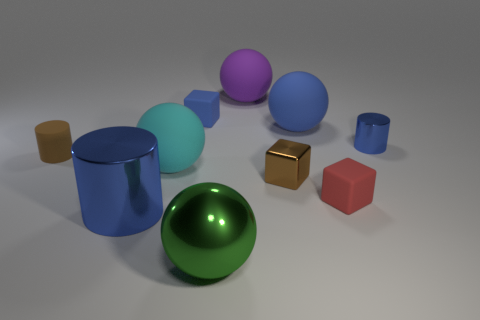What material is the blue thing that is in front of the rubber cube in front of the blue rubber thing that is left of the big blue rubber ball made of?
Make the answer very short. Metal. There is a green object; are there any metal objects behind it?
Ensure brevity in your answer.  Yes. The blue rubber object that is the same size as the brown block is what shape?
Keep it short and to the point. Cube. Are the big blue ball and the large purple sphere made of the same material?
Provide a succinct answer. Yes. What number of metallic things are tiny blue balls or spheres?
Your response must be concise. 1. What is the shape of the metallic object that is the same color as the large shiny cylinder?
Your answer should be very brief. Cylinder. Do the tiny rubber thing that is left of the large shiny cylinder and the tiny metal cube have the same color?
Give a very brief answer. Yes. There is a brown thing that is on the right side of the large purple sphere left of the brown shiny cube; what shape is it?
Your answer should be compact. Cube. What number of objects are red matte cubes in front of the big blue rubber object or tiny red blocks right of the blue cube?
Offer a very short reply. 1. The small blue object that is made of the same material as the cyan ball is what shape?
Your answer should be compact. Cube. 